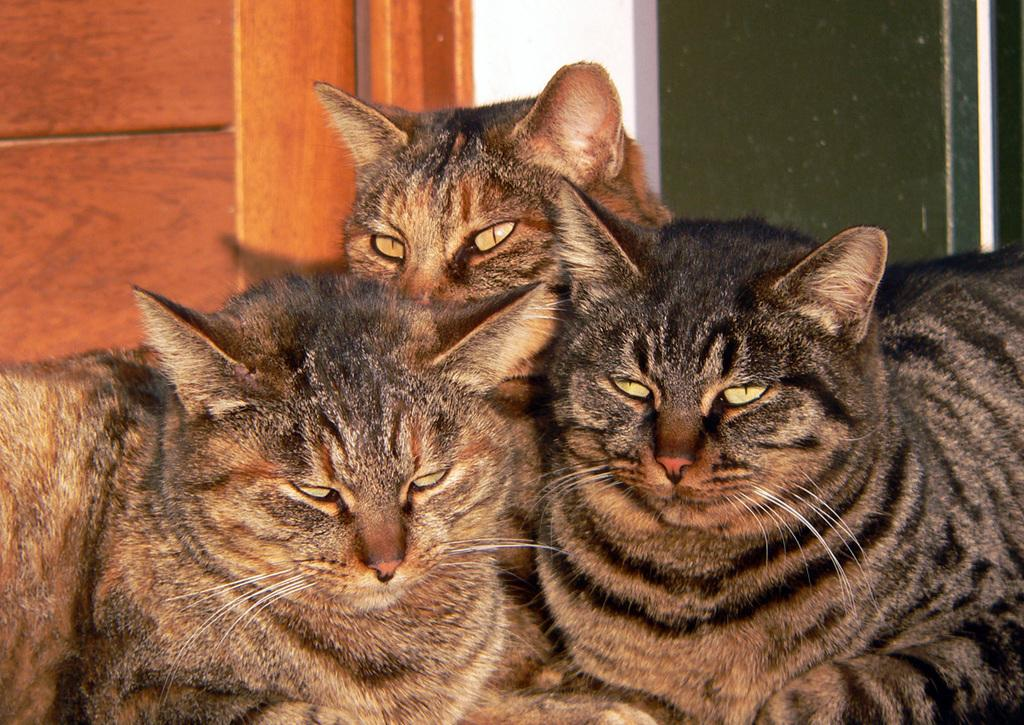How many cats are present in the image? There are three cats in the image. What type of crime is being committed by the cats in the image? There is no crime being committed by the cats in the image; they are simply present in the image. 